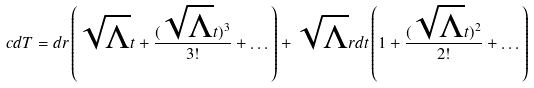<formula> <loc_0><loc_0><loc_500><loc_500>c d T = d r \left ( \sqrt { \Lambda } t + \frac { ( \sqrt { \Lambda } t ) ^ { 3 } } { 3 ! } + \dots \right ) + \sqrt { \Lambda } r d t \left ( 1 + \frac { ( \sqrt { \Lambda } t ) ^ { 2 } } { 2 ! } + \dots \right )</formula> 